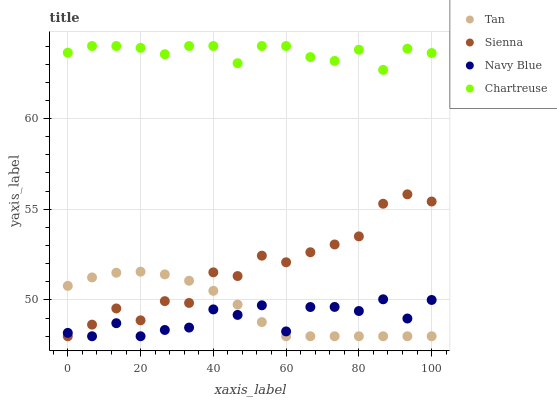Does Navy Blue have the minimum area under the curve?
Answer yes or no. Yes. Does Chartreuse have the maximum area under the curve?
Answer yes or no. Yes. Does Tan have the minimum area under the curve?
Answer yes or no. No. Does Tan have the maximum area under the curve?
Answer yes or no. No. Is Tan the smoothest?
Answer yes or no. Yes. Is Navy Blue the roughest?
Answer yes or no. Yes. Is Navy Blue the smoothest?
Answer yes or no. No. Is Tan the roughest?
Answer yes or no. No. Does Sienna have the lowest value?
Answer yes or no. Yes. Does Chartreuse have the lowest value?
Answer yes or no. No. Does Chartreuse have the highest value?
Answer yes or no. Yes. Does Tan have the highest value?
Answer yes or no. No. Is Sienna less than Chartreuse?
Answer yes or no. Yes. Is Chartreuse greater than Sienna?
Answer yes or no. Yes. Does Navy Blue intersect Sienna?
Answer yes or no. Yes. Is Navy Blue less than Sienna?
Answer yes or no. No. Is Navy Blue greater than Sienna?
Answer yes or no. No. Does Sienna intersect Chartreuse?
Answer yes or no. No. 